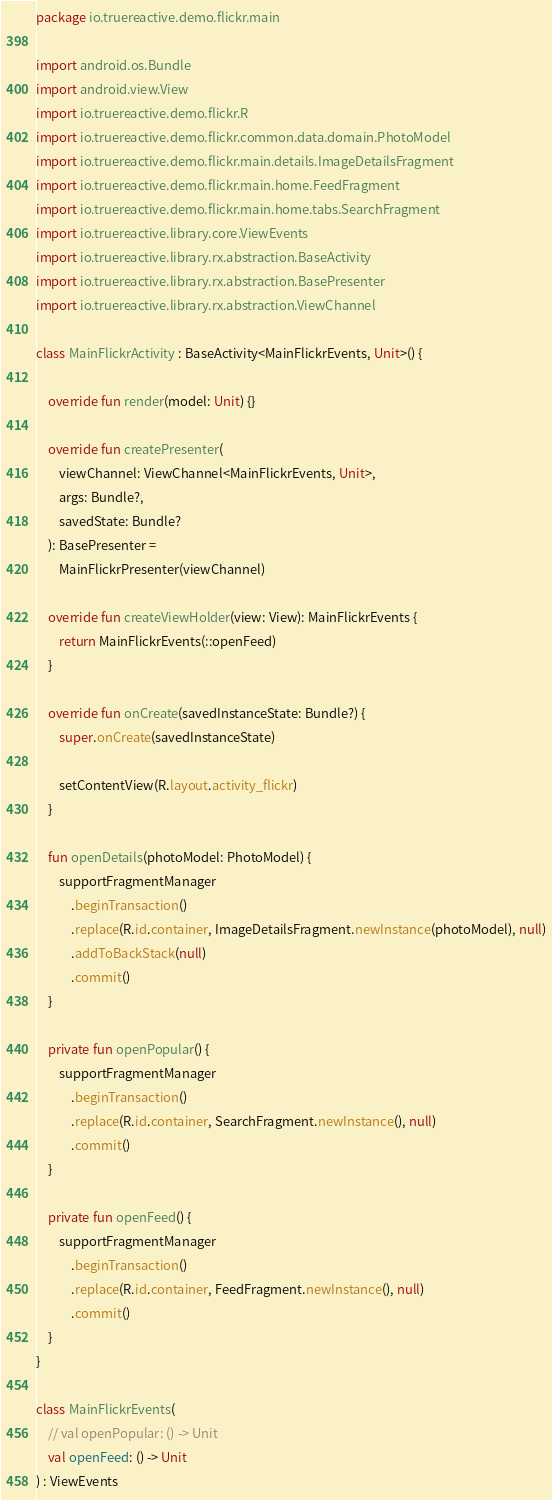<code> <loc_0><loc_0><loc_500><loc_500><_Kotlin_>package io.truereactive.demo.flickr.main

import android.os.Bundle
import android.view.View
import io.truereactive.demo.flickr.R
import io.truereactive.demo.flickr.common.data.domain.PhotoModel
import io.truereactive.demo.flickr.main.details.ImageDetailsFragment
import io.truereactive.demo.flickr.main.home.FeedFragment
import io.truereactive.demo.flickr.main.home.tabs.SearchFragment
import io.truereactive.library.core.ViewEvents
import io.truereactive.library.rx.abstraction.BaseActivity
import io.truereactive.library.rx.abstraction.BasePresenter
import io.truereactive.library.rx.abstraction.ViewChannel

class MainFlickrActivity : BaseActivity<MainFlickrEvents, Unit>() {

    override fun render(model: Unit) {}

    override fun createPresenter(
        viewChannel: ViewChannel<MainFlickrEvents, Unit>,
        args: Bundle?,
        savedState: Bundle?
    ): BasePresenter =
        MainFlickrPresenter(viewChannel)

    override fun createViewHolder(view: View): MainFlickrEvents {
        return MainFlickrEvents(::openFeed)
    }

    override fun onCreate(savedInstanceState: Bundle?) {
        super.onCreate(savedInstanceState)

        setContentView(R.layout.activity_flickr)
    }

    fun openDetails(photoModel: PhotoModel) {
        supportFragmentManager
            .beginTransaction()
            .replace(R.id.container, ImageDetailsFragment.newInstance(photoModel), null)
            .addToBackStack(null)
            .commit()
    }

    private fun openPopular() {
        supportFragmentManager
            .beginTransaction()
            .replace(R.id.container, SearchFragment.newInstance(), null)
            .commit()
    }

    private fun openFeed() {
        supportFragmentManager
            .beginTransaction()
            .replace(R.id.container, FeedFragment.newInstance(), null)
            .commit()
    }
}

class MainFlickrEvents(
    // val openPopular: () -> Unit
    val openFeed: () -> Unit
) : ViewEvents</code> 